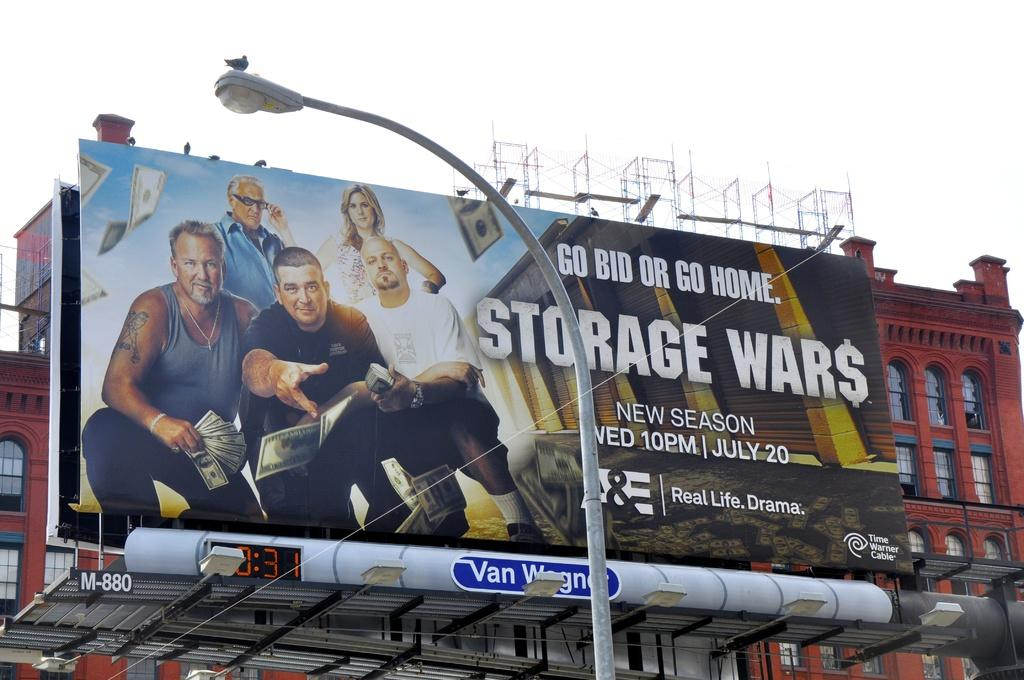<image>
Present a compact description of the photo's key features. a billboard that says 'go bid or go home, storage wars' on it 